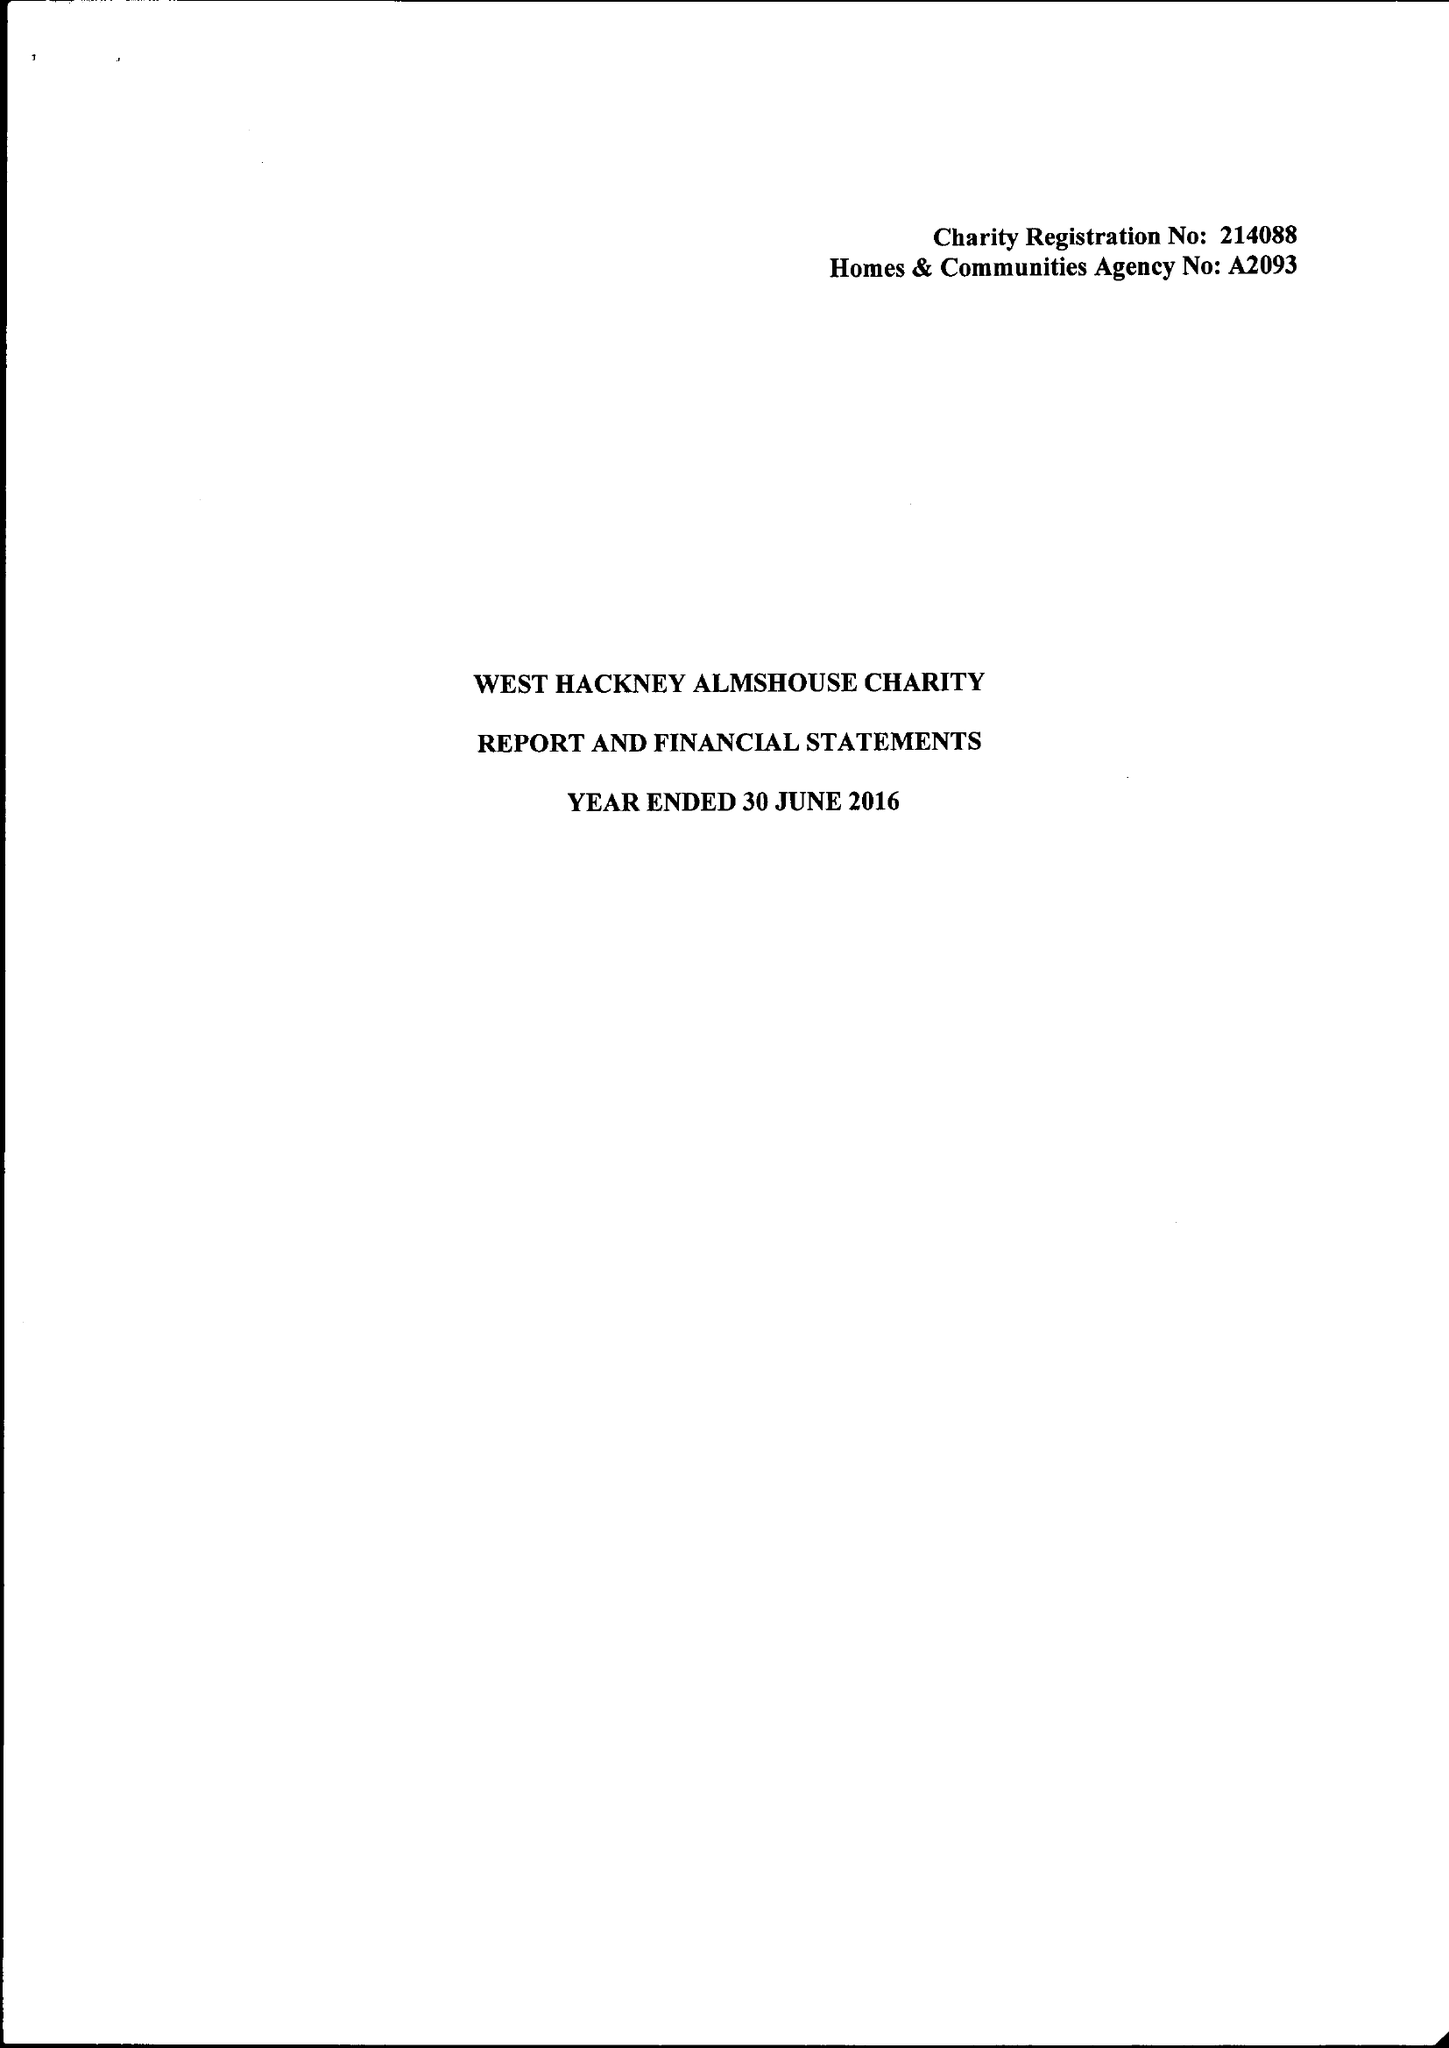What is the value for the income_annually_in_british_pounds?
Answer the question using a single word or phrase. 72680.00 